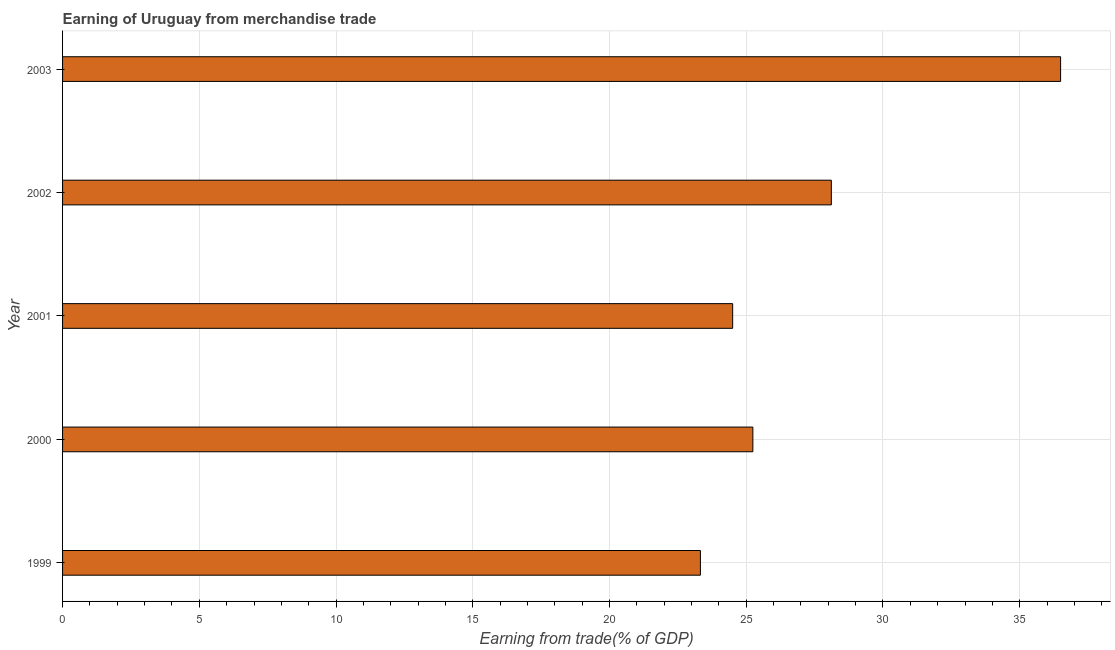What is the title of the graph?
Ensure brevity in your answer.  Earning of Uruguay from merchandise trade. What is the label or title of the X-axis?
Offer a terse response. Earning from trade(% of GDP). What is the earning from merchandise trade in 2001?
Provide a short and direct response. 24.5. Across all years, what is the maximum earning from merchandise trade?
Offer a terse response. 36.49. Across all years, what is the minimum earning from merchandise trade?
Your answer should be compact. 23.32. What is the sum of the earning from merchandise trade?
Provide a succinct answer. 137.68. What is the difference between the earning from merchandise trade in 2000 and 2001?
Make the answer very short. 0.74. What is the average earning from merchandise trade per year?
Your response must be concise. 27.54. What is the median earning from merchandise trade?
Make the answer very short. 25.24. In how many years, is the earning from merchandise trade greater than 24 %?
Provide a short and direct response. 4. Do a majority of the years between 2000 and 2001 (inclusive) have earning from merchandise trade greater than 21 %?
Make the answer very short. Yes. What is the ratio of the earning from merchandise trade in 2000 to that in 2003?
Your response must be concise. 0.69. What is the difference between the highest and the second highest earning from merchandise trade?
Provide a short and direct response. 8.38. What is the difference between the highest and the lowest earning from merchandise trade?
Your response must be concise. 13.17. How many bars are there?
Provide a short and direct response. 5. How many years are there in the graph?
Your answer should be compact. 5. What is the Earning from trade(% of GDP) of 1999?
Provide a short and direct response. 23.32. What is the Earning from trade(% of GDP) of 2000?
Your answer should be compact. 25.24. What is the Earning from trade(% of GDP) in 2001?
Offer a terse response. 24.5. What is the Earning from trade(% of GDP) in 2002?
Offer a very short reply. 28.11. What is the Earning from trade(% of GDP) in 2003?
Provide a short and direct response. 36.49. What is the difference between the Earning from trade(% of GDP) in 1999 and 2000?
Offer a terse response. -1.92. What is the difference between the Earning from trade(% of GDP) in 1999 and 2001?
Keep it short and to the point. -1.18. What is the difference between the Earning from trade(% of GDP) in 1999 and 2002?
Provide a short and direct response. -4.79. What is the difference between the Earning from trade(% of GDP) in 1999 and 2003?
Offer a very short reply. -13.17. What is the difference between the Earning from trade(% of GDP) in 2000 and 2001?
Provide a short and direct response. 0.74. What is the difference between the Earning from trade(% of GDP) in 2000 and 2002?
Provide a succinct answer. -2.87. What is the difference between the Earning from trade(% of GDP) in 2000 and 2003?
Provide a short and direct response. -11.25. What is the difference between the Earning from trade(% of GDP) in 2001 and 2002?
Offer a very short reply. -3.61. What is the difference between the Earning from trade(% of GDP) in 2001 and 2003?
Ensure brevity in your answer.  -11.99. What is the difference between the Earning from trade(% of GDP) in 2002 and 2003?
Ensure brevity in your answer.  -8.38. What is the ratio of the Earning from trade(% of GDP) in 1999 to that in 2000?
Keep it short and to the point. 0.92. What is the ratio of the Earning from trade(% of GDP) in 1999 to that in 2002?
Ensure brevity in your answer.  0.83. What is the ratio of the Earning from trade(% of GDP) in 1999 to that in 2003?
Your response must be concise. 0.64. What is the ratio of the Earning from trade(% of GDP) in 2000 to that in 2001?
Your answer should be very brief. 1.03. What is the ratio of the Earning from trade(% of GDP) in 2000 to that in 2002?
Provide a short and direct response. 0.9. What is the ratio of the Earning from trade(% of GDP) in 2000 to that in 2003?
Offer a very short reply. 0.69. What is the ratio of the Earning from trade(% of GDP) in 2001 to that in 2002?
Your answer should be very brief. 0.87. What is the ratio of the Earning from trade(% of GDP) in 2001 to that in 2003?
Ensure brevity in your answer.  0.67. What is the ratio of the Earning from trade(% of GDP) in 2002 to that in 2003?
Your response must be concise. 0.77. 